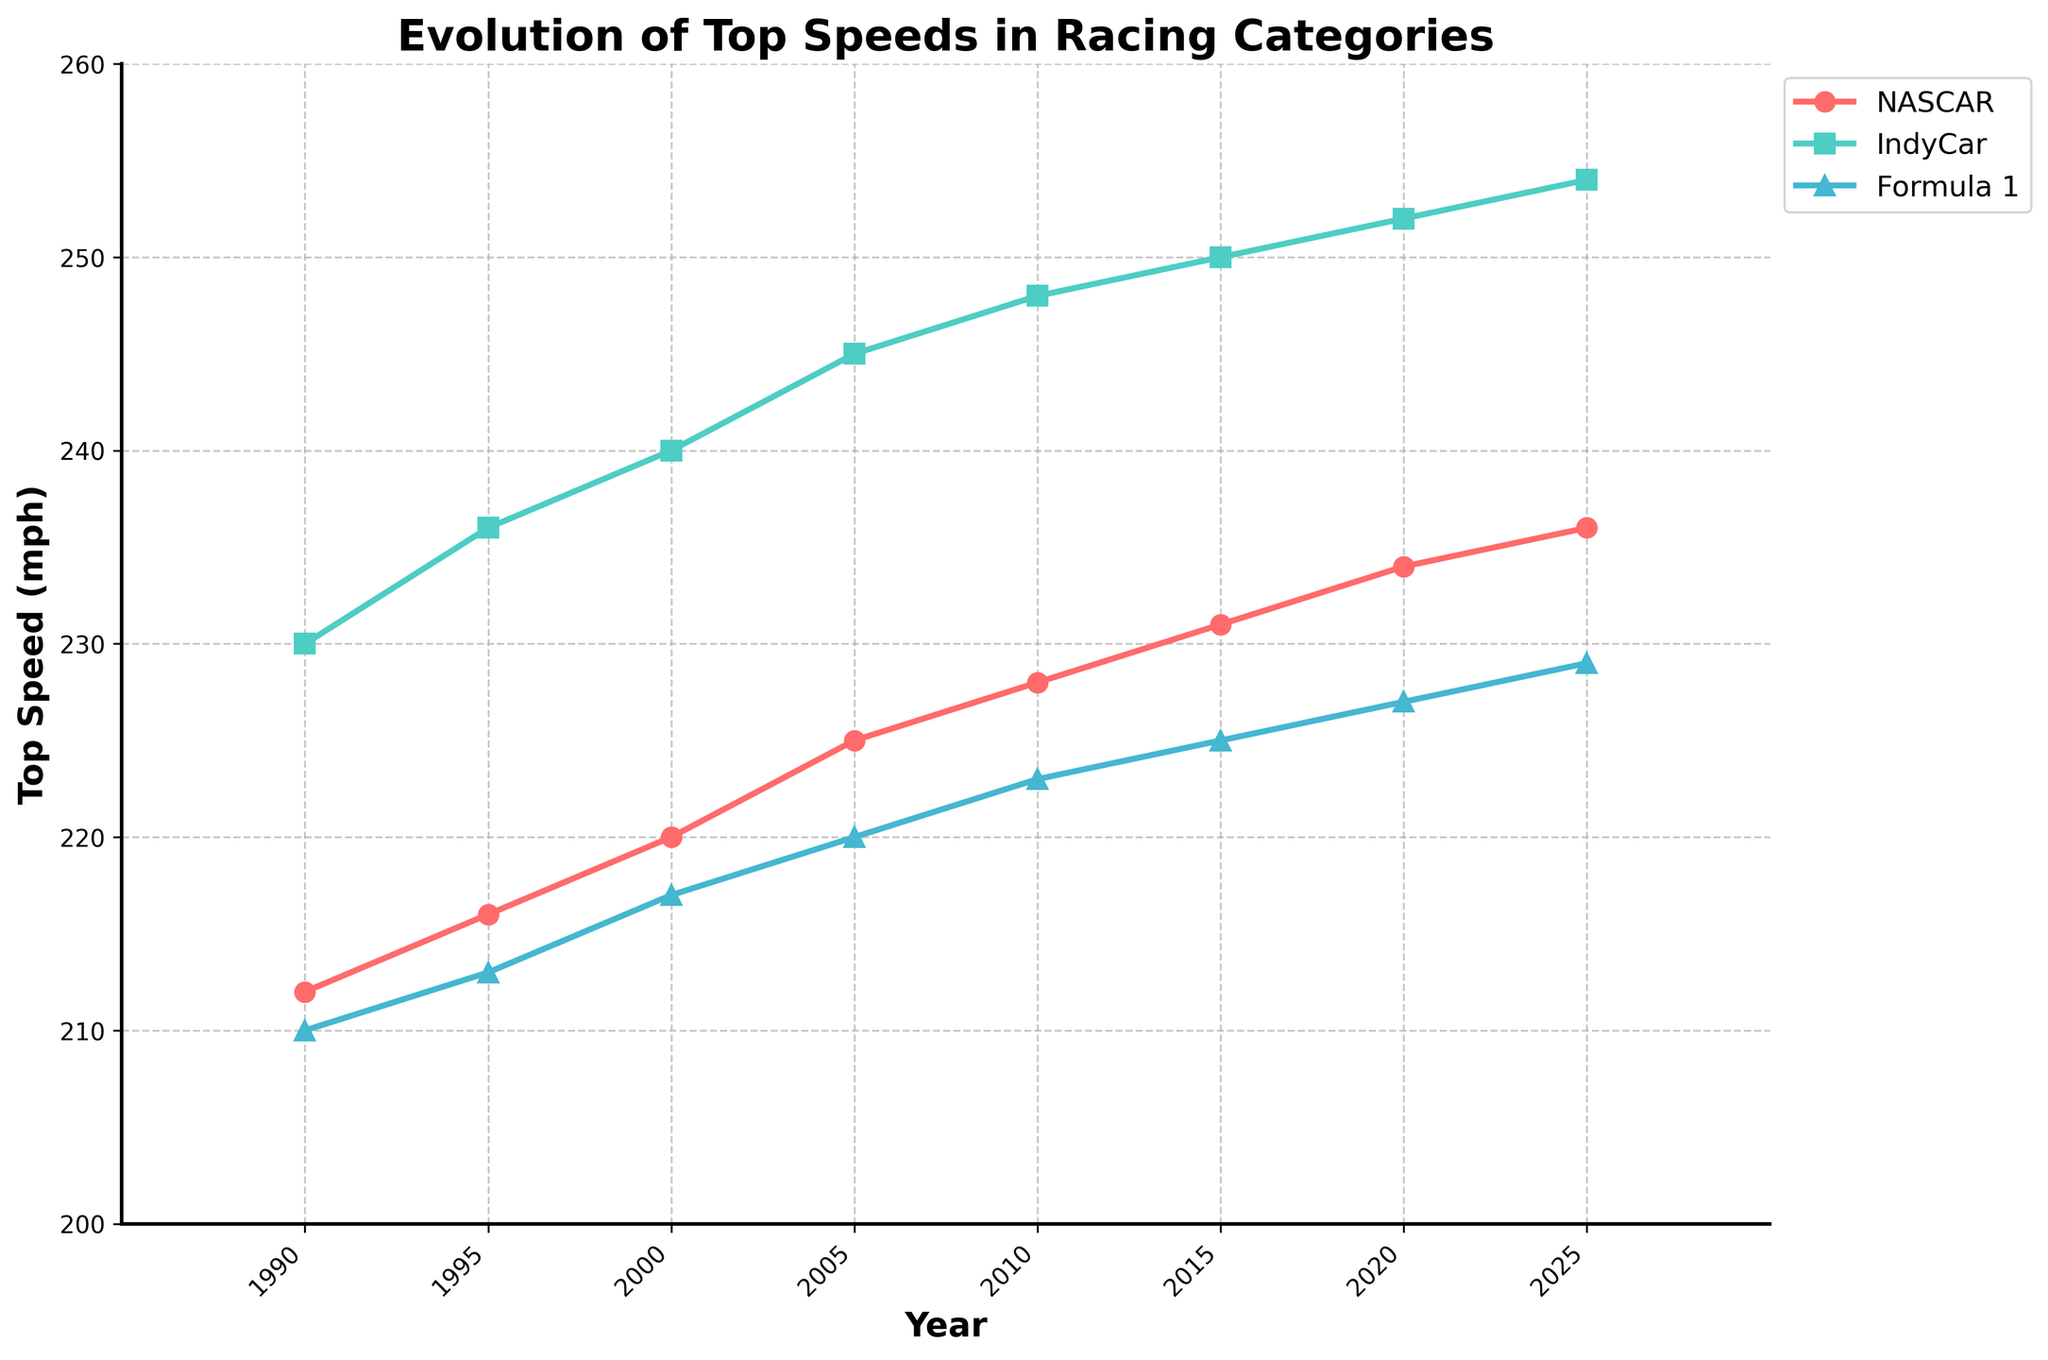What year did Formula 1 reach a top speed of 225 mph? From the line chart, find where the line representing Formula 1 intersects with the 225 mph mark on the y-axis. The corresponding x-axis value is the year.
Answer: 2015 Which racing category had the highest top speed in 2025? Locate the data points on the line chart for the year 2025. Compare the y-values (top speeds) of NASCAR, IndyCar, and Formula 1 to find the highest.
Answer: IndyCar By how much did the top speed of NASCAR increase from 1995 to 2020? Find the top speeds of NASCAR for 1995 and 2020 from the line chart. Subtract the 1995 value from the 2020 value: 234 mph - 216 mph = 18 mph.
Answer: 18 mph Which racing category showed the most significant overall increase in top speed over the past three decades? Calculate the difference in top speeds from 1990 to 2020 for NASCAR, IndyCar, and Formula 1. Whichever category has the largest difference is the answer. IndyCar: 252 - 230 = 22 mph; NASCAR: 234 - 212 = 22 mph; Formula 1: 227 - 210 = 17 mph. Both NASCAR and IndyCar increased most significantly.
Answer: NASCAR and IndyCar What is the average top speed of IndyCar over the years shown? Sum the top speeds of IndyCar for all the years provided and divide by the number of data points: (230 + 236 + 240 + 245 + 248 + 250 + 252 + 254)/8. The sum is 1955, and the average is 1955/8 = 244.375.
Answer: 244.375 Describe the trend in top speeds for Formula 1 over the past three decades. Observe the line representing Formula 1. It starts at 210 mph in 1990 and generally increases steadily until 2025 where it reaches 229 mph.
Answer: Steady increase In which years were the top speeds of NASCAR less than those of Formula 1? Compare the top speed values year by year for NASCAR and Formula 1. The years where NASCAR's top speed is less than Formula 1 are 1995 and 2020.
Answer: 1995, 2020 How much faster was IndyCar compared to NASCAR in 2010? Find the top speeds for both IndyCar and NASCAR in 2010 from the line chart. Subtract NASCAR’s speed from IndyCar’s speed: 248 mph - 228 mph = 20 mph.
Answer: 20 mph What color represents IndyCar on the chart? Look at the legend on the line chart. Identify which color is assigned to IndyCar.
Answer: Green 